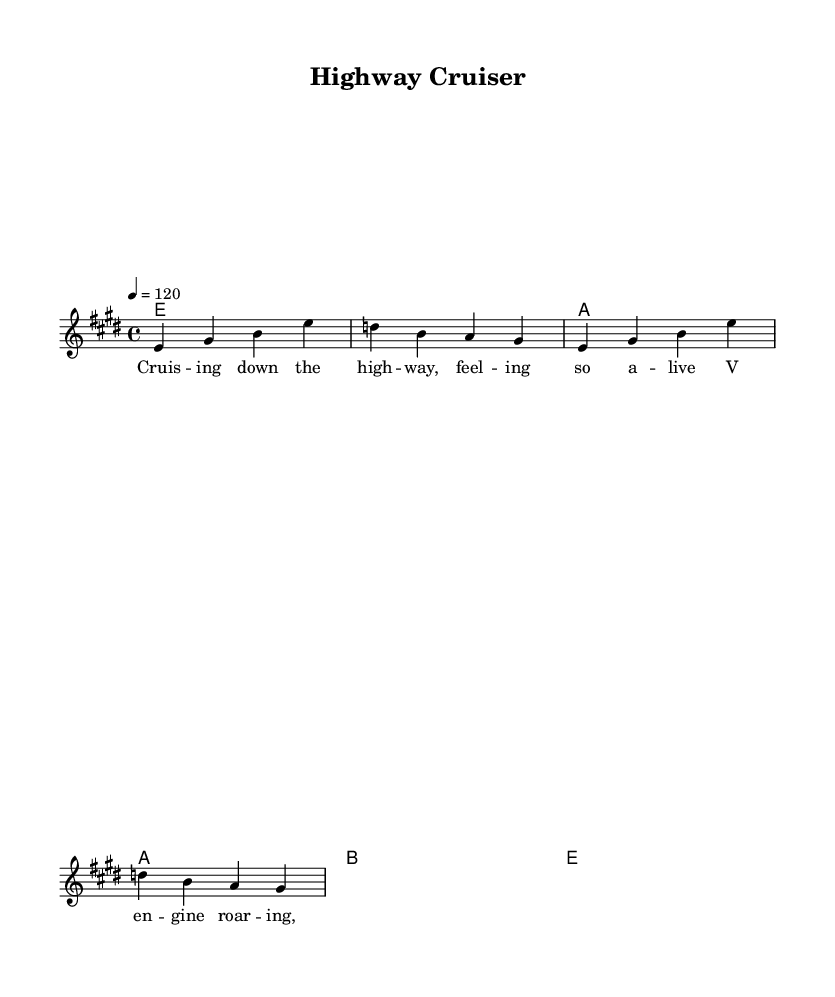What is the key signature of this music? The key signature is E major, which consists of four sharps: F#, C#, G#, and D#.
Answer: E major What is the time signature of this piece? The time signature is 4/4, which indicates that there are four beats in a measure and the quarter note gets one beat.
Answer: 4/4 What is the tempo marking of the music? The tempo marking indicates a speed of 120 beats per minute, which is considered a moderate tempo.
Answer: 120 How many measures are in the melody section? The melody consists of two complete phrases, each containing four measures, totaling eight measures overall.
Answer: 8 What type of harmonies are used in this piece? The harmonies include major chords, specifically E major and A major, indicating a tonal, harmonically rich background.
Answer: Major What is the primary lyrical theme of the song? The lyrics describe the experience of driving on the highway, evoking feelings of freedom and excitement associated with cruising in a car.
Answer: Cruising down the highway Which voice is used for the melody? The melody is assigned to the lead voice, which is indicated in the score's labeling as "lead".
Answer: Lead 